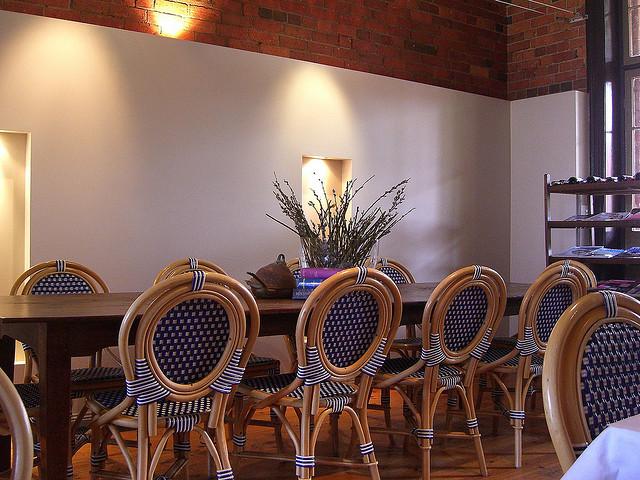What are the chairs made off?
Give a very brief answer. Wood. Is this a dinner setting?
Quick response, please. Yes. Is there exposed brick on the walls?
Be succinct. Yes. 